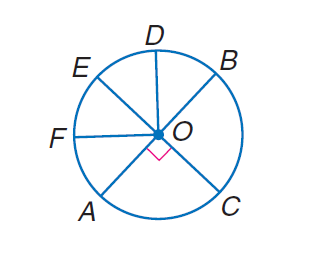Answer the mathemtical geometry problem and directly provide the correct option letter.
Question: In \odot O, E C and A B are diameters, and \angle B O D \cong \angle D O E \cong \angle E O F \cong \angle F O A. Find m \widehat B C.
Choices: A: 45 B: 90 C: 180 D: 360 B 